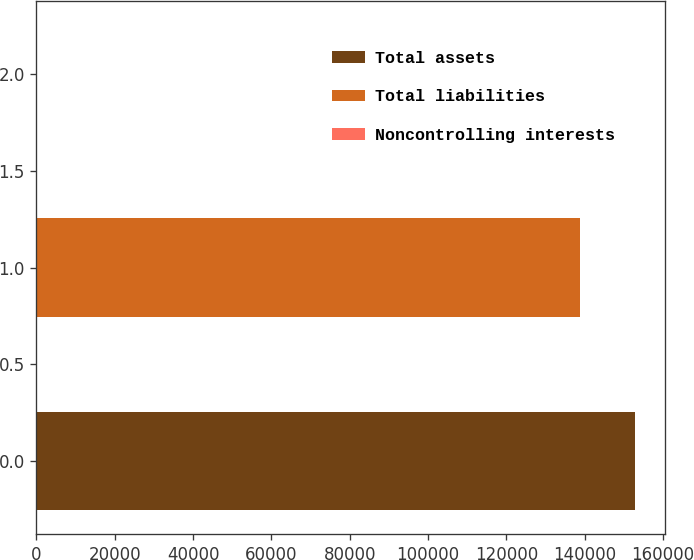Convert chart to OTSL. <chart><loc_0><loc_0><loc_500><loc_500><bar_chart><fcel>Total assets<fcel>Total liabilities<fcel>Noncontrolling interests<nl><fcel>152901<fcel>138742<fcel>41<nl></chart> 